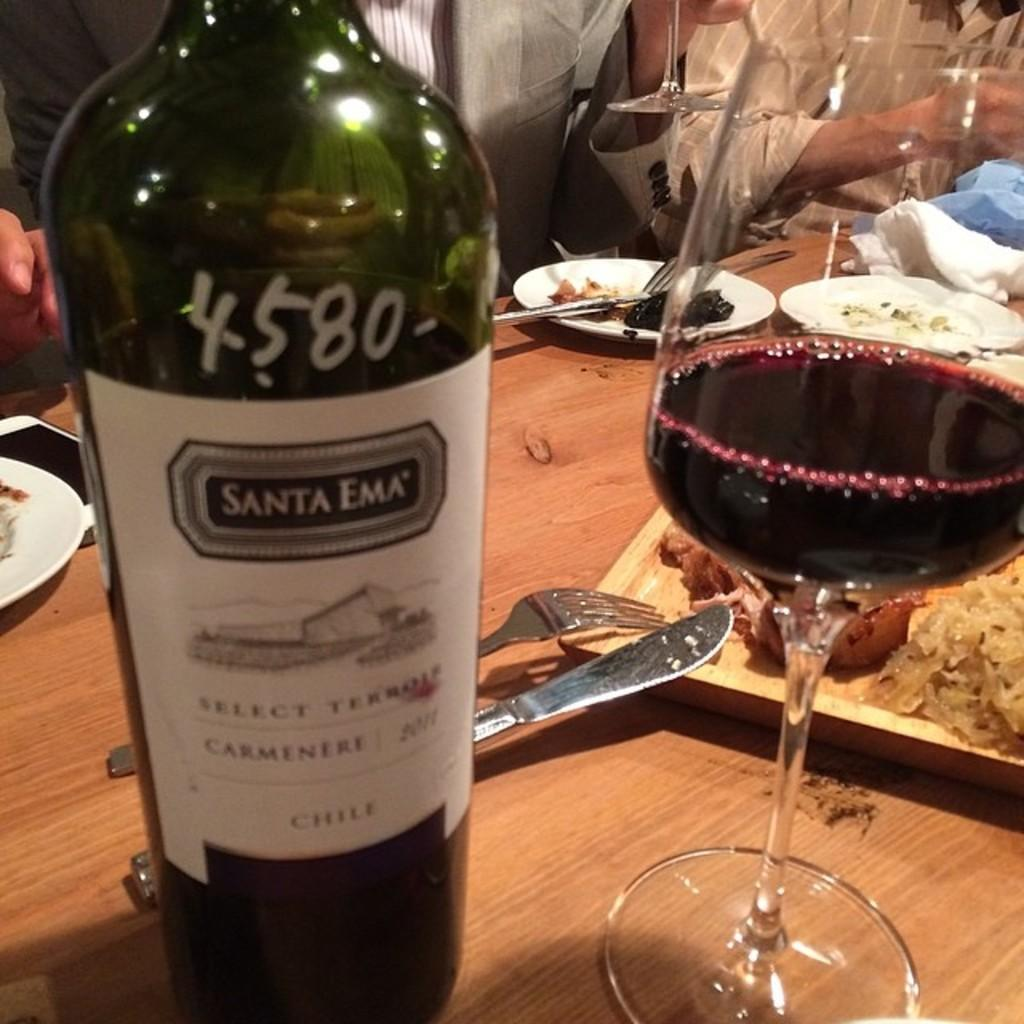<image>
Write a terse but informative summary of the picture. A bottle of Santa Ema with 4580 written on it. 